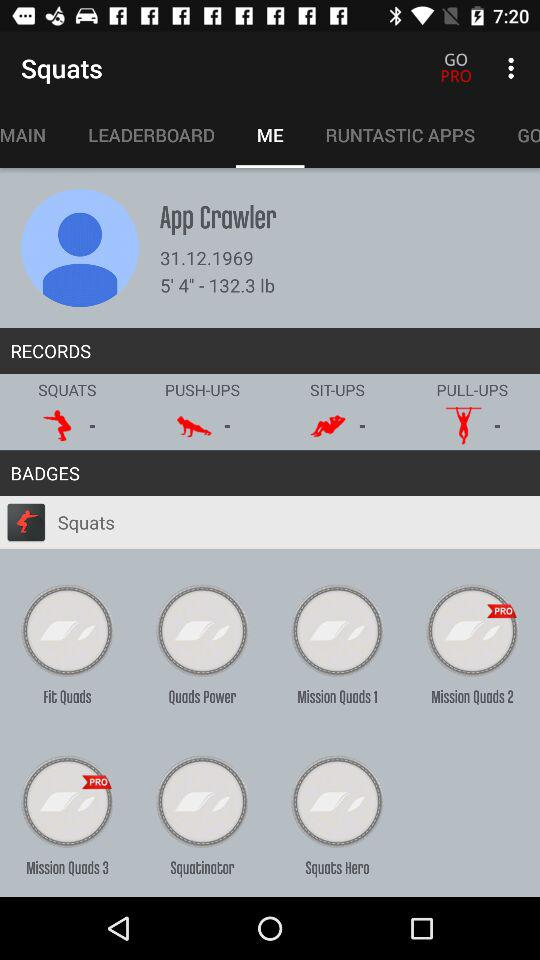What's the user's profile name? The user's profile name is App Crawler. 